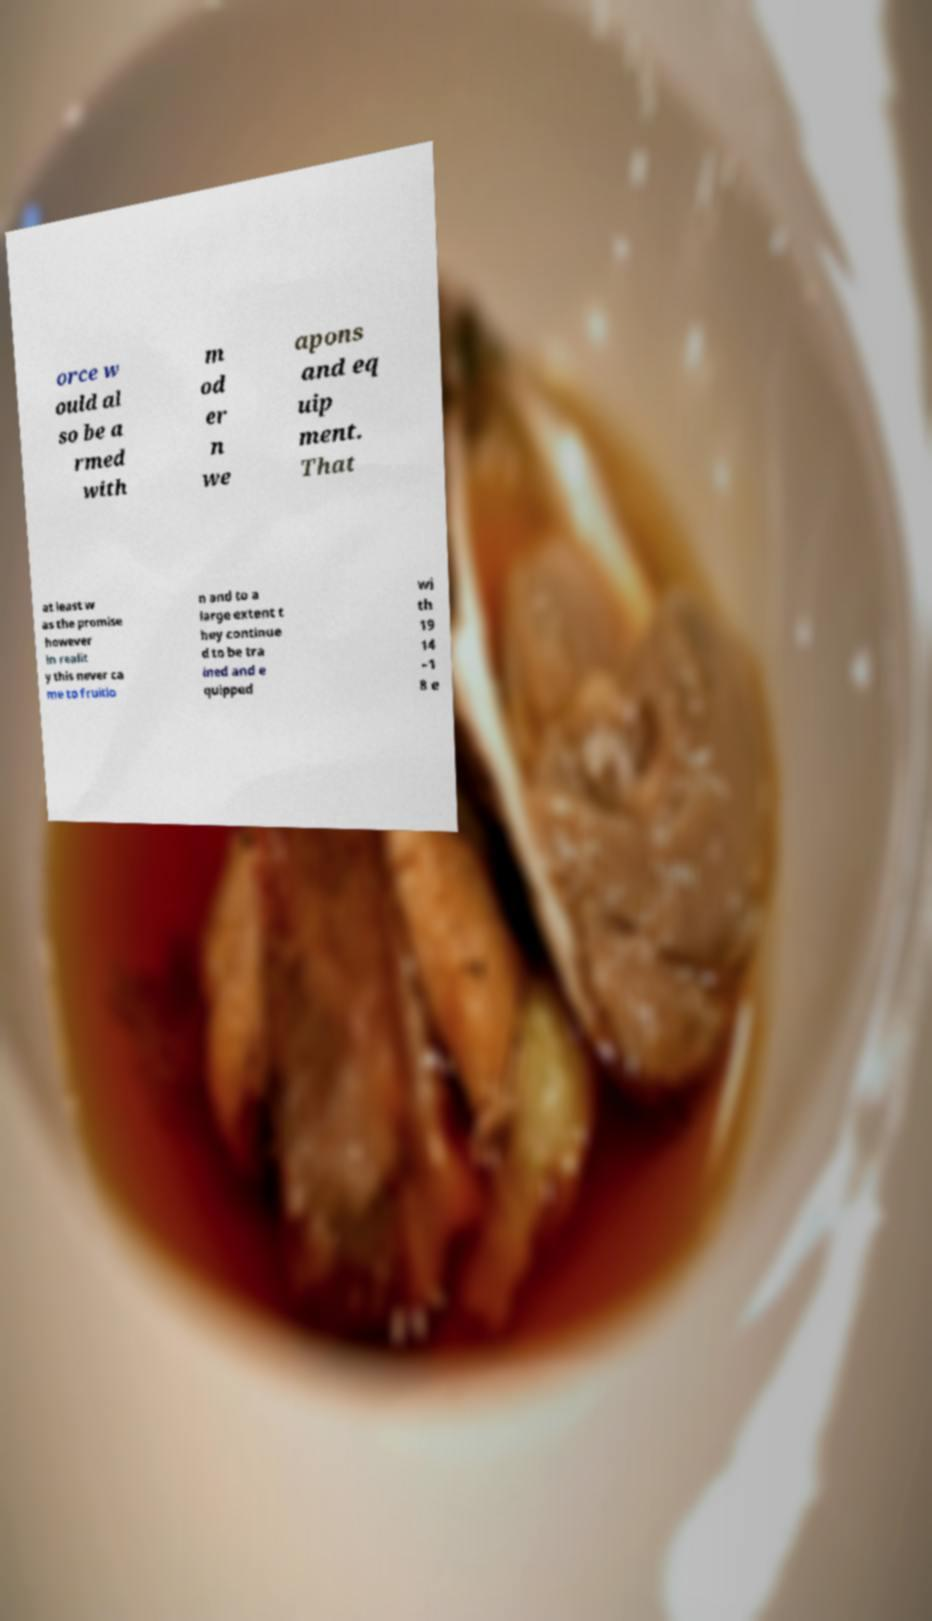Can you read and provide the text displayed in the image?This photo seems to have some interesting text. Can you extract and type it out for me? orce w ould al so be a rmed with m od er n we apons and eq uip ment. That at least w as the promise however in realit y this never ca me to fruitio n and to a large extent t hey continue d to be tra ined and e quipped wi th 19 14 –1 8 e 